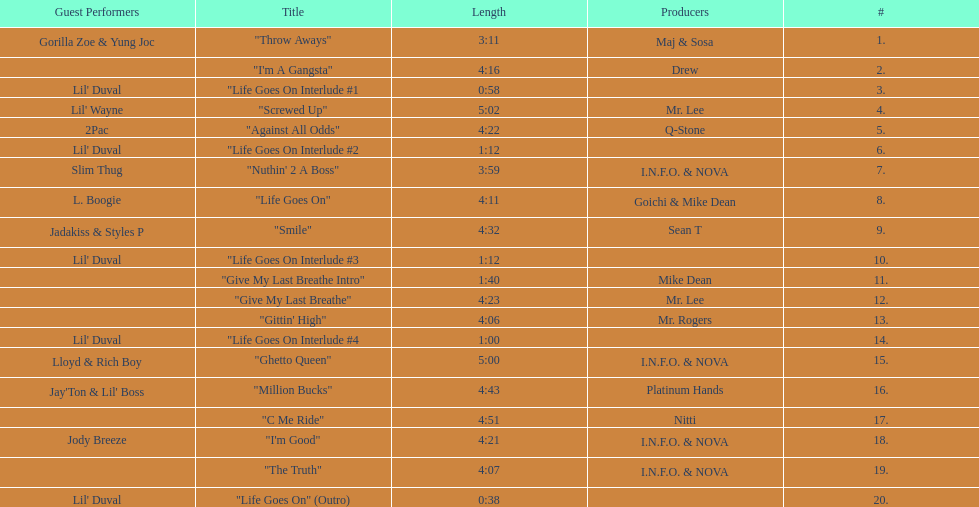What is the number of tracks on trae's "life goes on" album? 20. 